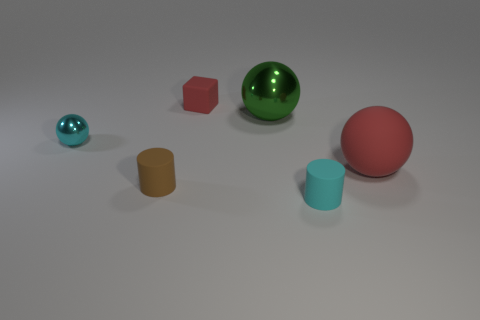What is the size of the cyan shiny sphere?
Offer a very short reply. Small. How many blocks have the same size as the red rubber sphere?
Ensure brevity in your answer.  0. There is a tiny cyan object that is the same shape as the green object; what is it made of?
Give a very brief answer. Metal. What shape is the object that is both behind the tiny sphere and to the left of the green thing?
Keep it short and to the point. Cube. What is the shape of the shiny object that is to the left of the green shiny object?
Provide a succinct answer. Sphere. How many objects are to the left of the cyan cylinder and behind the small brown cylinder?
Ensure brevity in your answer.  3. Is the size of the cyan rubber object the same as the red thing that is to the left of the big rubber thing?
Keep it short and to the point. Yes. There is a metallic ball that is right of the tiny cyan object left of the red object that is to the left of the small cyan rubber object; what is its size?
Provide a short and direct response. Large. How big is the ball behind the cyan metallic sphere?
Provide a succinct answer. Large. There is a small cyan thing that is the same material as the large green sphere; what shape is it?
Your answer should be very brief. Sphere. 